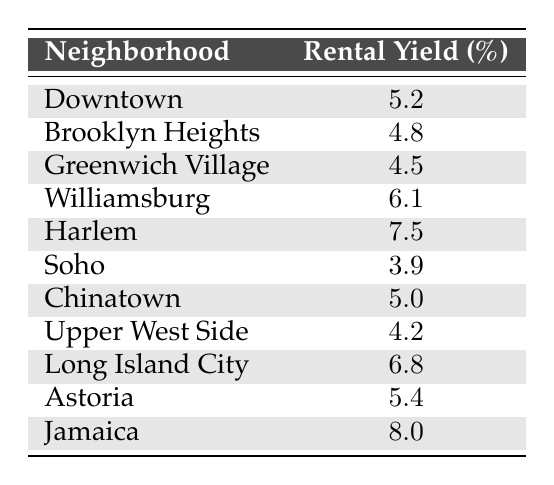What is the rental yield in Harlem? Looking at the table, Harlem has a rental yield percentage listed next to it. The entry for Harlem shows a rental yield of 7.5.
Answer: 7.5 Which neighborhood has the lowest rental yield? To find the neighborhood with the lowest rental yield, we look at all the entries and identify the one with the smallest percentage. Soho has the lowest rental yield at 3.9.
Answer: Soho Calculate the average rental yield of Long Island City and Williamsburg. We need to find the rental yields for both Long Island City (6.8) and Williamsburg (6.1) and then average them. The sum of the yields is 6.8 + 6.1 = 12.9. Since there are 2 neighborhoods, we divide by 2. Thus, the average is 12.9 / 2 = 6.45.
Answer: 6.45 Is the rental yield in Brooklyn Heights higher than the yield in Chinatown? We check the rental yields from the table: Brooklyn Heights has a yield of 4.8, while Chinatown has a yield of 5.0. Thus, Brooklyn Heights does not exceed Chinatown's yield, leading to a "no" conclusion.
Answer: No What is the difference between the highest and lowest rental yields? The highest rental yield is from Jamaica at 8.0 and the lowest is from Soho at 3.9. To find the difference, we subtract the lowest from the highest: 8.0 - 3.9 = 4.1.
Answer: 4.1 Are there more neighborhoods with rental yields above 5% than those below? From the table, the neighborhoods with yields above 5% are Downtown, Williamsburg, Harlem, Long Island City, Astoria, and Jamaica (6 total). Below 5% are Brooklyn Heights, Greenwich Village, Soho, and Upper West Side (4 total). Since there are 6 above and 4 below, we can confidently say there are more above 5%.
Answer: Yes Which neighborhood has a rental yield closest to the overall average of the listed neighborhoods? First, we find the overall average rental yield. Adding all yields gives us a total of 57.4. There are 11 neighborhoods, so the average is 57.4 / 11 = 5.22. Comparing this with each neighborhood's yield, Chinatown at 5.0 is closest to 5.22.
Answer: Chinatown How many neighborhoods have a rental yield of 5% or higher? By examining the table, we can count the neighborhoods: Downtown, Williamsburg, Harlem, Long Island City, Astoria, and Jamaica, amounting to a total of 6 neighborhoods.
Answer: 6 